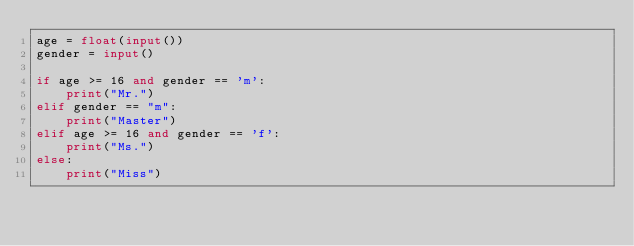<code> <loc_0><loc_0><loc_500><loc_500><_Python_>age = float(input())
gender = input()

if age >= 16 and gender == 'm':
    print("Mr.")
elif gender == "m":
    print("Master")
elif age >= 16 and gender == 'f':
    print("Ms.")
else:
    print("Miss")
</code> 